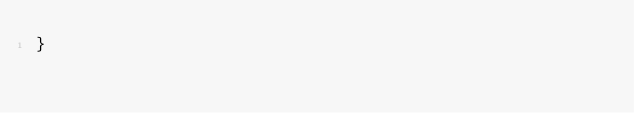<code> <loc_0><loc_0><loc_500><loc_500><_Java_>}
</code> 